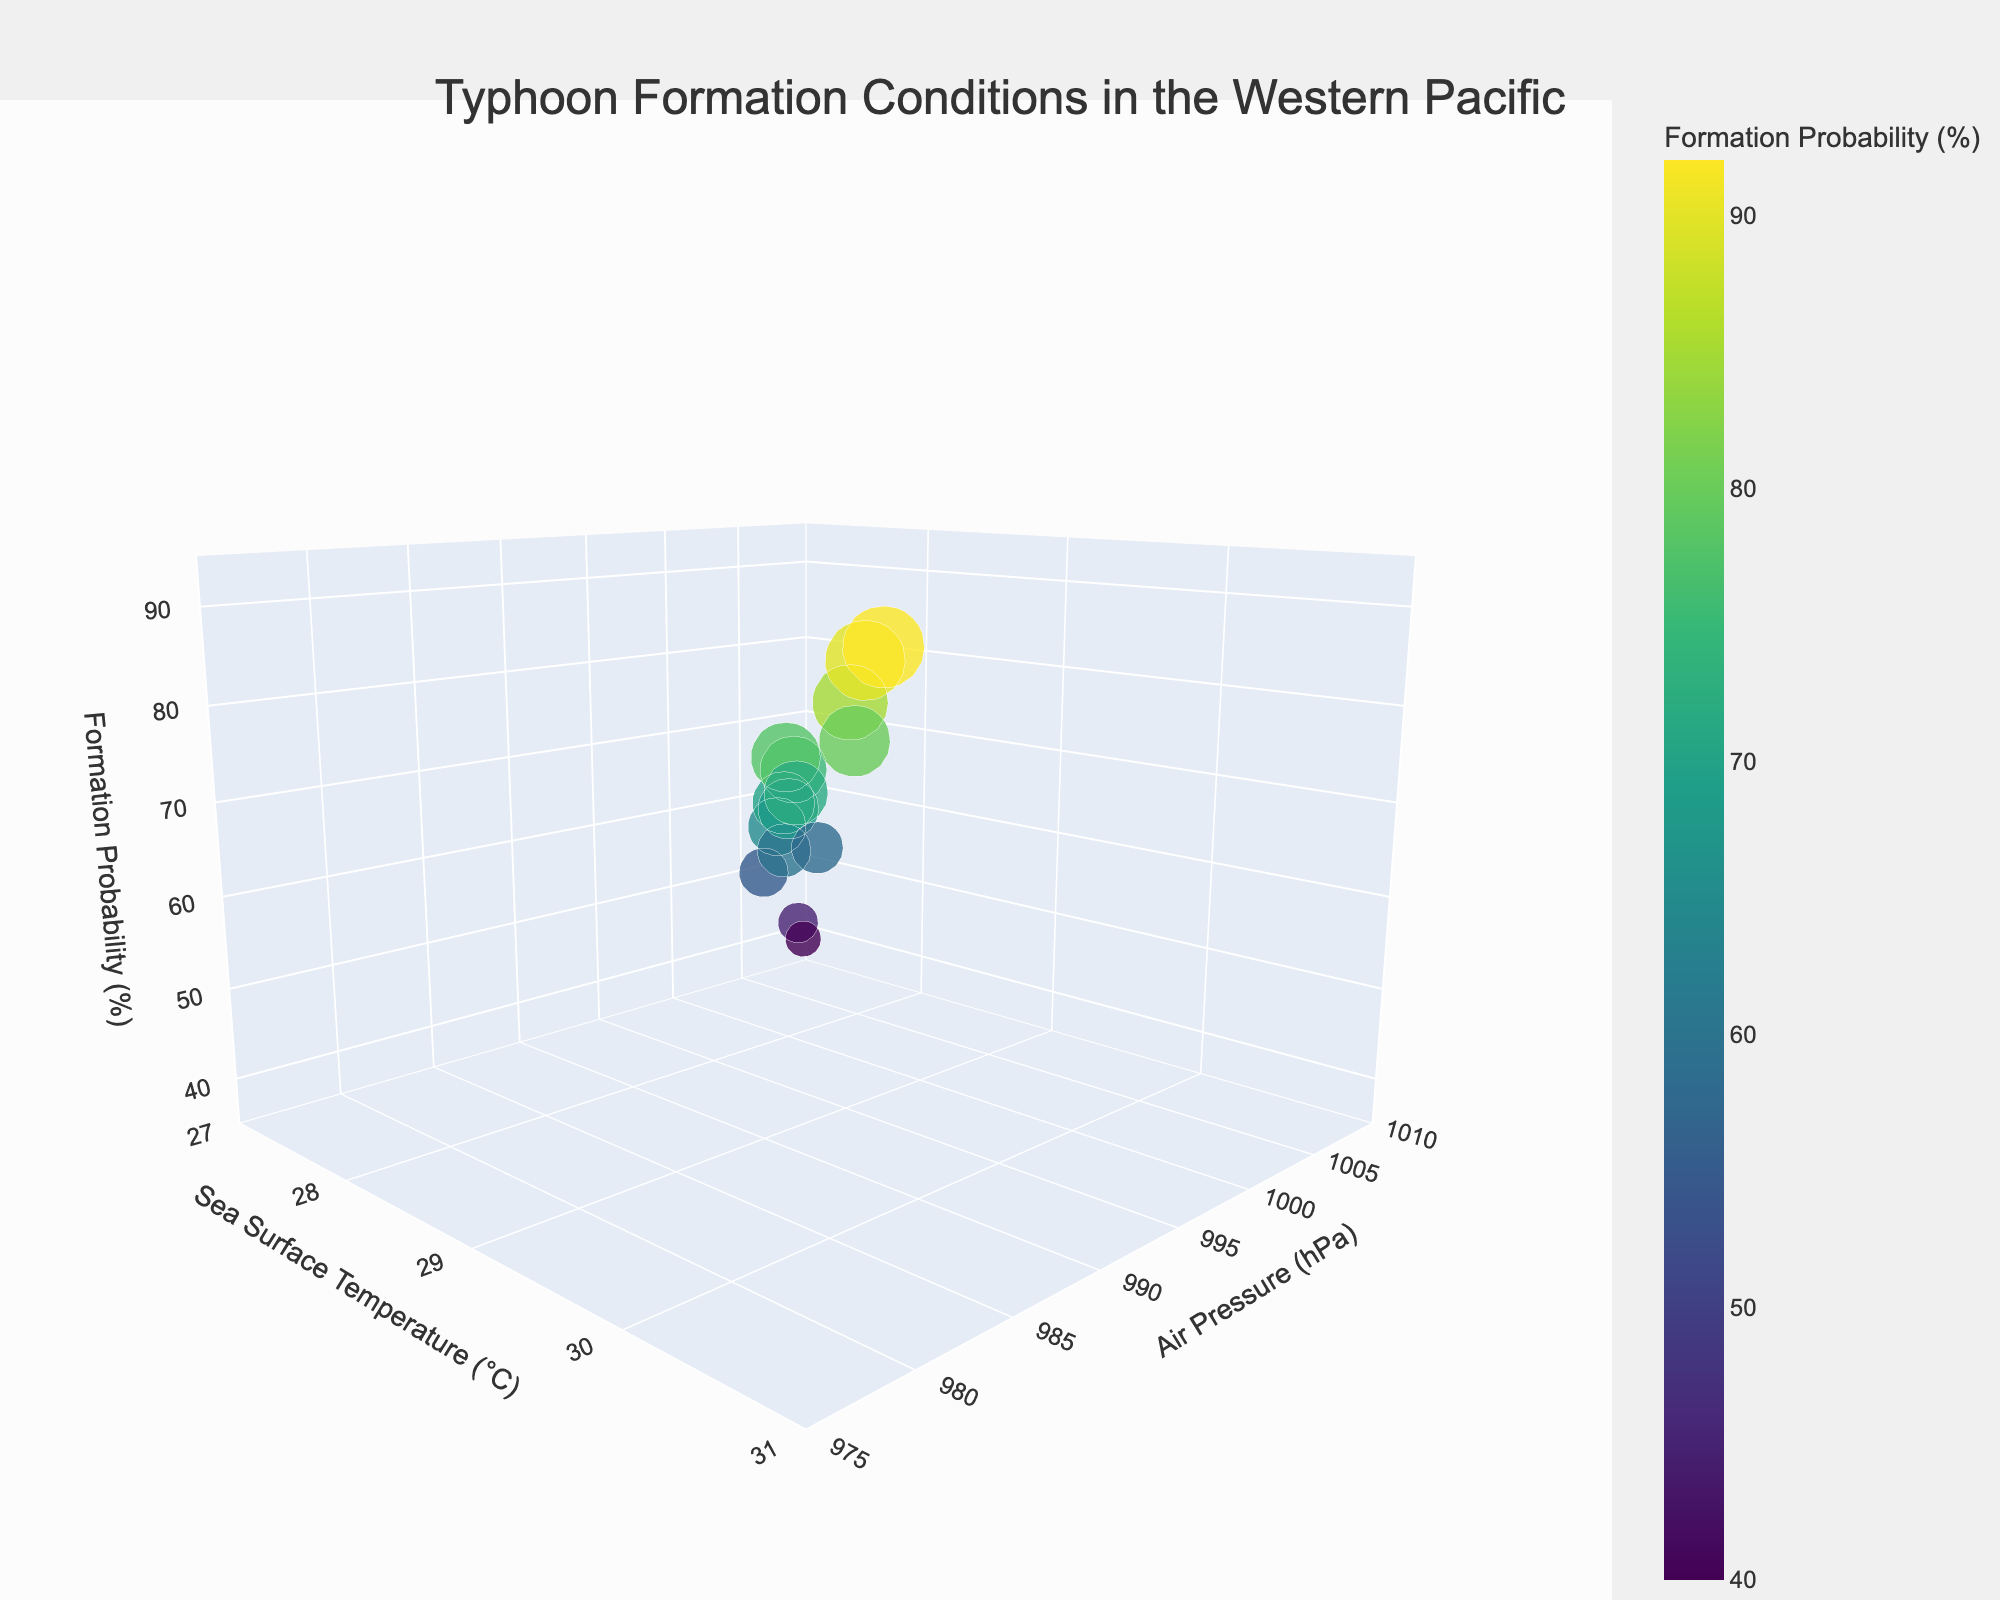What is the title of the figure? The title is centrally located at the top of the figure and is formatted in bold text with a larger font size.
Answer: Typhoon Formation Conditions in the Western Pacific How many different typhoons are represented in the plot? Each bubble corresponds to a distinct typhoon, and by counting the data points, it is evident that 15 typhoons are depicted.
Answer: 15 What is the range of sea surface temperature values shown in the figure? The sea surface temperature axis ranges from 27°C to 31°C, as indicated by the axis labels and ticks.
Answer: 27°C to 31°C Which typhoon has the highest formation probability? The bubble representing the highest formation probability is located at the top of the z-axis, and the hover information identifies this typhoon as Merbok.
Answer: Merbok What's the average air pressure of typhoons with a formation probability over 80%? Identifying the typhoons with formation probabilities over 80% (Hinnamnor, Rai, Merbok) and averaging their air pressures (985, 982, 980 hPa), the calculation is (985+982+980)/3 = 982.33 hPa.
Answer: 982.33 hPa Which typhoon has the largest bubble size, and what does it represent? The largest bubble, which signifies the typhoon with the highest formation probability, is Merbok.
Answer: Merbok; represents 92% Do higher sea surface temperatures generally correspond to higher formation probabilities? Observing the scatter of data points, there is a trend where higher sea surface temperatures (e.g., those around 30°C) are associated with higher formation probabilities.
Answer: Yes Which typhoon has the lowest air pressure, and what is its formation probability? The bubble at the lowest point on the air pressure axis (980 hPa) corresponds to Merbok, which has a formation probability of 92%.
Answer: Merbok; 92% Compare the formation probabilities of typhoons Hinnamnor and In-fa. Which one is higher and by how much? Hinnamnor has a formation probability of 85%, while In-fa has 45%. The difference is calculated as 85% - 45% = 40%.
Answer: Hinnamnor; 40% Is there a typhoon with a sea surface temperature below 28°C and an air pressure above 1000 hPa? The figure shows data points below 28°C (such as 27.8°C) and those above 1000 hPa (such as 1005 hPa), but no single typhoon matches both criteria simultaneously.
Answer: No 